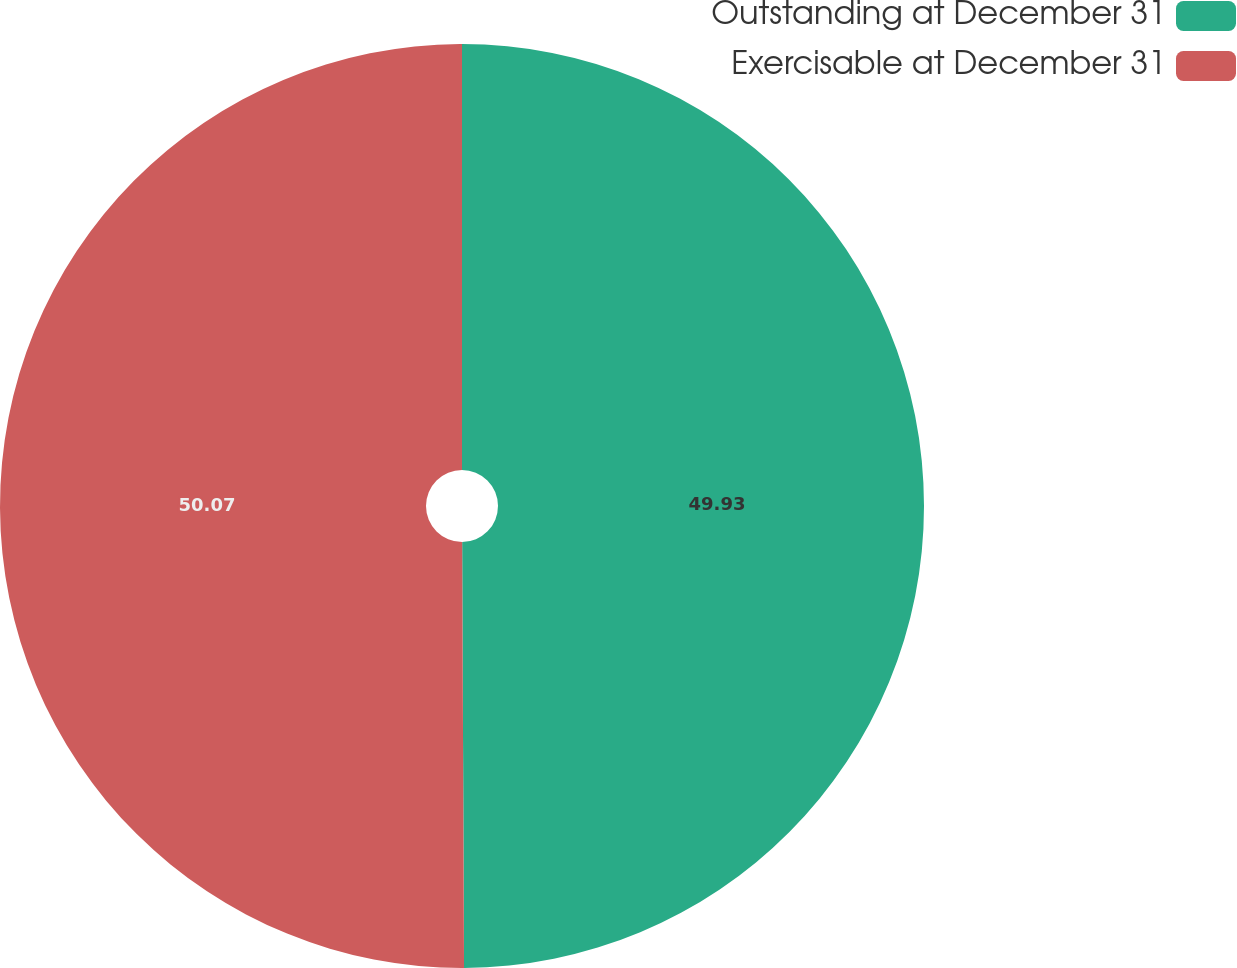<chart> <loc_0><loc_0><loc_500><loc_500><pie_chart><fcel>Outstanding at December 31<fcel>Exercisable at December 31<nl><fcel>49.93%<fcel>50.07%<nl></chart> 